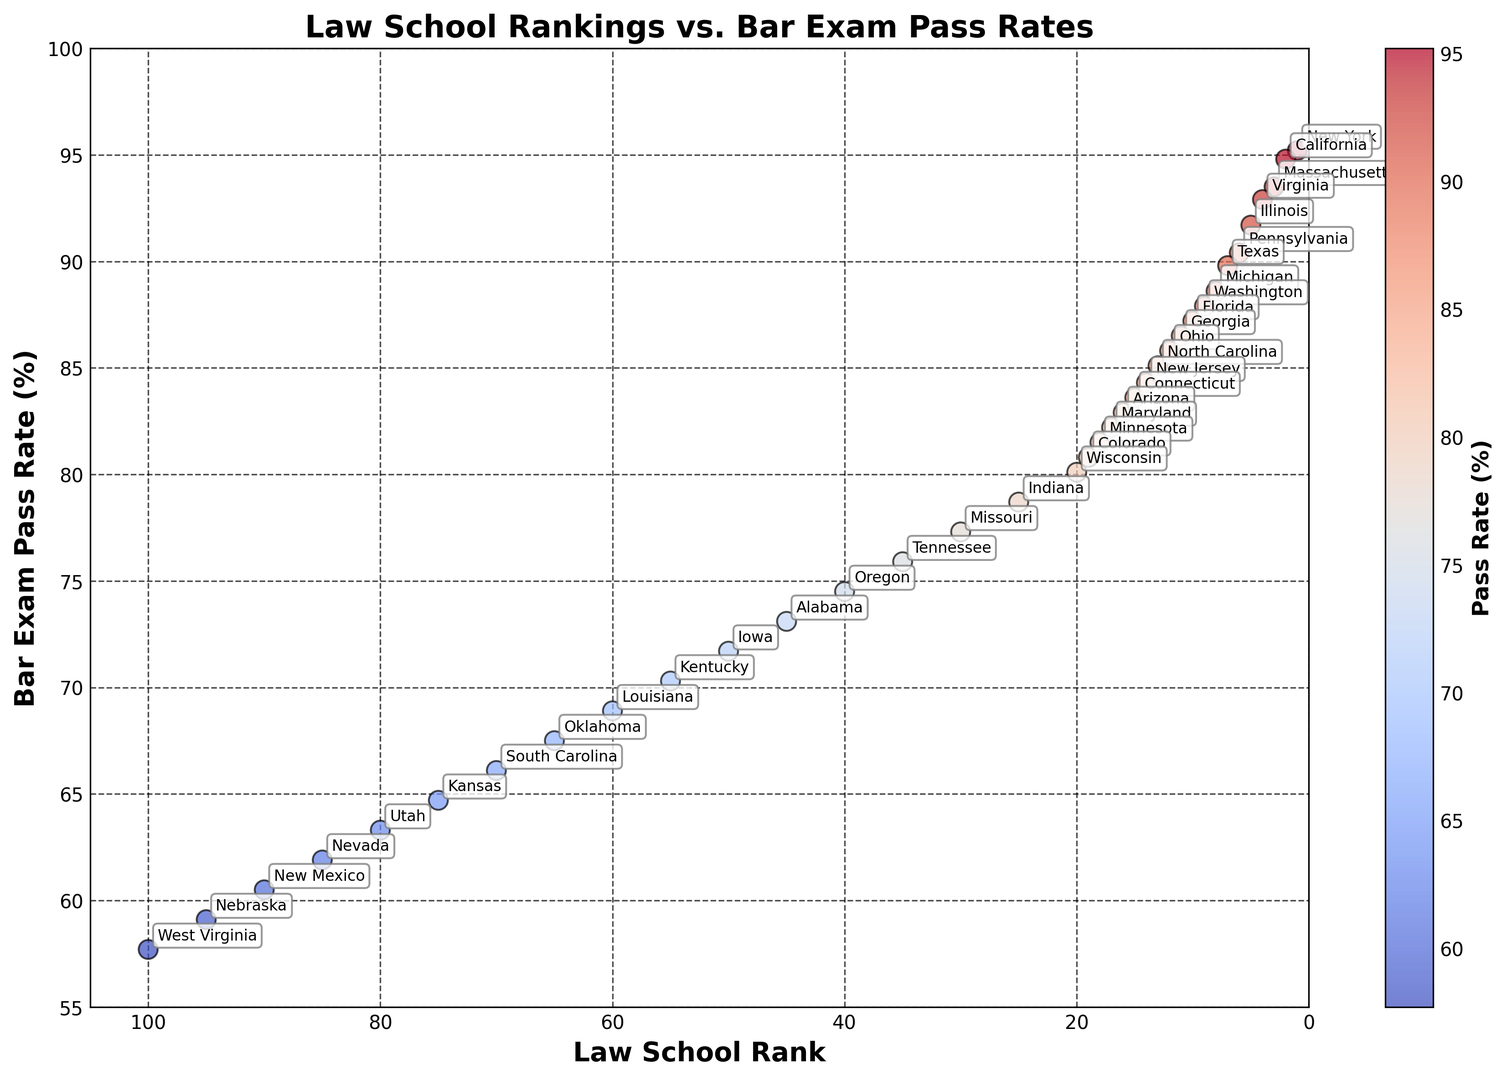Which state has the highest bar exam pass rate? The scatter plot shows each state's bar exam pass rate with annotations. Identify the point with the highest value on the y-axis, which corresponds to the highest bar exam pass rate.
Answer: New York Does every state with a top 5 law school ranking have a bar exam pass rate above 90%? Check the scatter points associated with law school rankings 1 to 5. Verify if their bar exam pass rates are all above 90% on the y-axis.
Answer: Yes What is the difference in bar exam pass rate between New York and West Virginia? Identify the points for New York and West Virginia on the scatter plot. Subtract the bar exam pass rate of West Virginia from that of New York.
Answer: 37.5% Which two states have the closest bar exam pass rates, but different law school rankings? Look for points with closely positioned y-values (bar exam pass rates) but different x-values (law school ranks). Compare and identify the closest pair.
Answer: Massachusetts and Virginia Is there a general trend between law school ranking and bar exam pass rate? Examine the overall distribution of points on the scatter plot. Check if there is a general direction or trend as the law school ranking increases or decreases.
Answer: Higher-ranked schools generally have higher pass rates Which clustering of colors indicates states with high bar exam pass rates? Inspect the scatter plot for clusters of points with similar colors that represent higher bar exam pass rates (cooler colors like red).
Answer: Top-left region Identify a state with a mid-range bar exam pass rate and a law school ranking close to 50. Find points that are in the middle range on the y-axis and check their x-axis values around 50.
Answer: Iowa What is the average bar exam pass rate for the top 10 ranked law schools? Identify the scatter points for the top 10 law school rankings. Sum their bar exam pass rates and divide by 10 to get the average.
Answer: 91.4% Which state has the highest bar exam pass rate among the states ranked 45 to 50? Locate the points for law school rankings 45 to 50 and compare their bar exam pass rates to find the highest.
Answer: Alabama How does the bar exam pass rate of Texas compare to that of Arizona? Identify the points for Texas and Arizona on the scatter plot. Check the y-values to compare the bar exam pass rates directly.
Answer: Texas is higher 